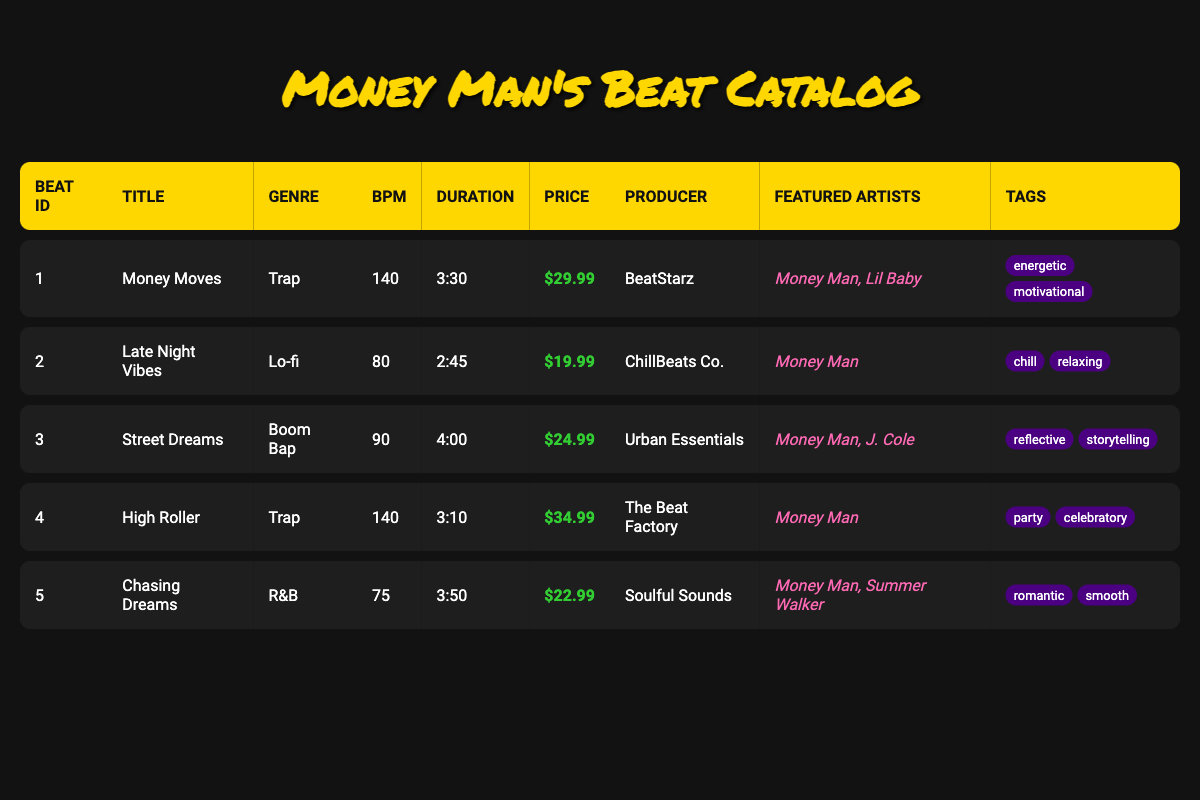What is the title of the beat with the highest price? The table displays beats with their respective prices. Looking at the price column, "High Roller" has the highest price listed at $34.99.
Answer: High Roller How many beats feature Money Man? By examining the "Featured Artists" column, I count three beats that include Money Man: "Money Moves," "Late Night Vibes," and "High Roller."
Answer: 3 What is the average BPM of all the beats listed? To find the average BPM, sum the BPMs: 140 + 80 + 90 + 140 + 75 = 525. There are 5 beats, so the average BPM is 525/5 = 105.
Answer: 105 Which genre has the most beats in this catalog? Looking through the genres, "Trap" appears twice (for "Money Moves" and "High Roller"), while "Lo-fi," "Boom Bap," and "R&B" appear once each. Hence, Trap has the most beats.
Answer: Trap Is there a beat with a duration longer than 4 minutes? Reviewing the duration column, only "Street Dreams" at 4:00 exceeds 4 minutes, confirming the statement is true.
Answer: Yes What is the total price of all the beats? Summing up the prices: 29.99 + 19.99 + 24.99 + 34.99 + 22.99 = 132.95. Thus, the total price of all beats is $132.95.
Answer: 132.95 Which beat has a chill tag and is produced by ChillBeats Co.? Looking at the tags and producer column, "Late Night Vibes" produced by ChillBeats Co. is tagged as "chill."
Answer: Late Night Vibes Are there any beats that feature both Money Man and J. Cole? From the list, the only beat featuring both artists is "Street Dreams." Therefore, the answer is affirmative.
Answer: Yes 